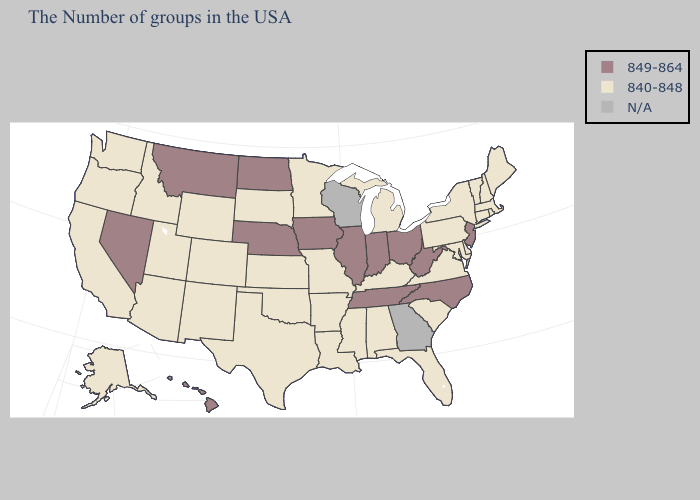Name the states that have a value in the range 849-864?
Give a very brief answer. New Jersey, North Carolina, West Virginia, Ohio, Indiana, Tennessee, Illinois, Iowa, Nebraska, North Dakota, Montana, Nevada, Hawaii. Name the states that have a value in the range 849-864?
Give a very brief answer. New Jersey, North Carolina, West Virginia, Ohio, Indiana, Tennessee, Illinois, Iowa, Nebraska, North Dakota, Montana, Nevada, Hawaii. Name the states that have a value in the range 840-848?
Answer briefly. Maine, Massachusetts, Rhode Island, New Hampshire, Vermont, Connecticut, New York, Delaware, Maryland, Pennsylvania, Virginia, South Carolina, Florida, Michigan, Kentucky, Alabama, Mississippi, Louisiana, Missouri, Arkansas, Minnesota, Kansas, Oklahoma, Texas, South Dakota, Wyoming, Colorado, New Mexico, Utah, Arizona, Idaho, California, Washington, Oregon, Alaska. What is the lowest value in the USA?
Answer briefly. 840-848. Which states have the highest value in the USA?
Concise answer only. New Jersey, North Carolina, West Virginia, Ohio, Indiana, Tennessee, Illinois, Iowa, Nebraska, North Dakota, Montana, Nevada, Hawaii. What is the value of Wyoming?
Write a very short answer. 840-848. What is the value of Arizona?
Short answer required. 840-848. What is the value of Maine?
Answer briefly. 840-848. What is the value of Montana?
Short answer required. 849-864. Is the legend a continuous bar?
Concise answer only. No. What is the lowest value in states that border New Hampshire?
Give a very brief answer. 840-848. Does Ohio have the lowest value in the USA?
Keep it brief. No. 